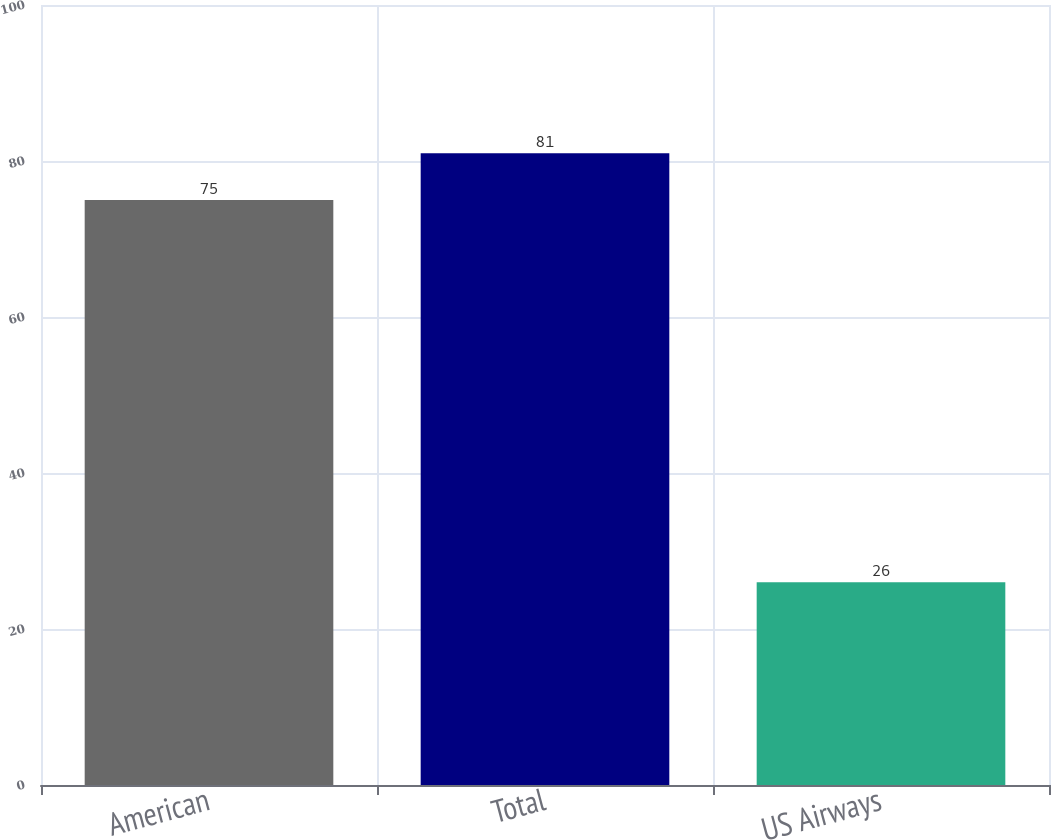<chart> <loc_0><loc_0><loc_500><loc_500><bar_chart><fcel>American<fcel>Total<fcel>US Airways<nl><fcel>75<fcel>81<fcel>26<nl></chart> 